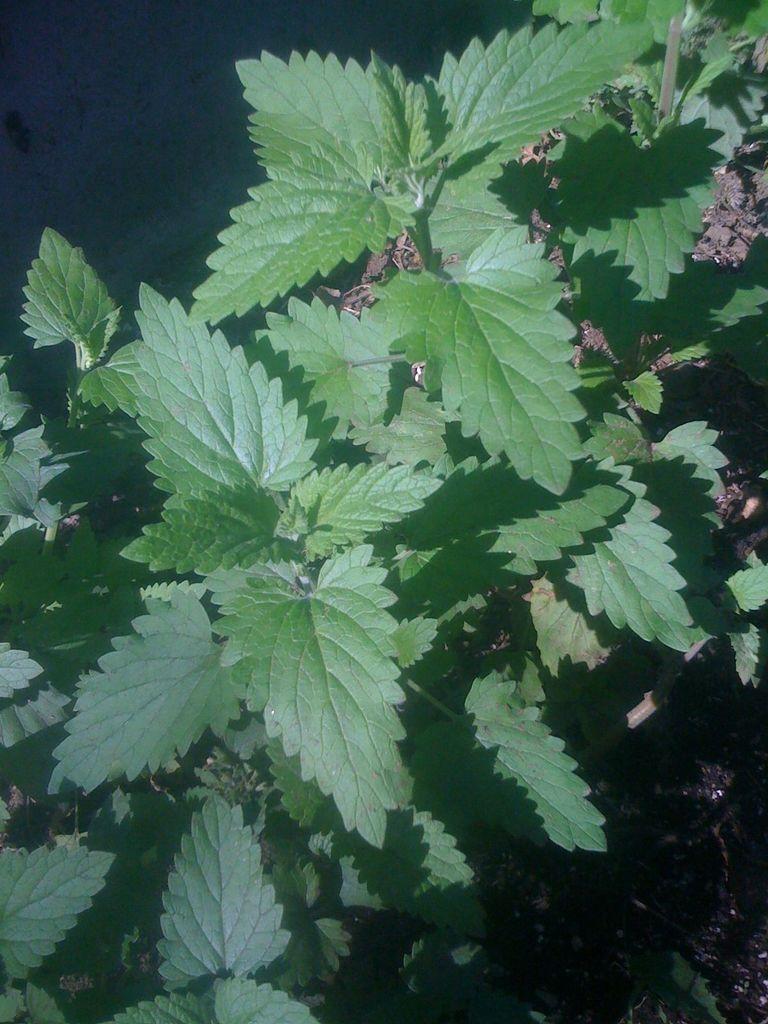Could you give a brief overview of what you see in this image? In this image I can see number of green colour leaves. 